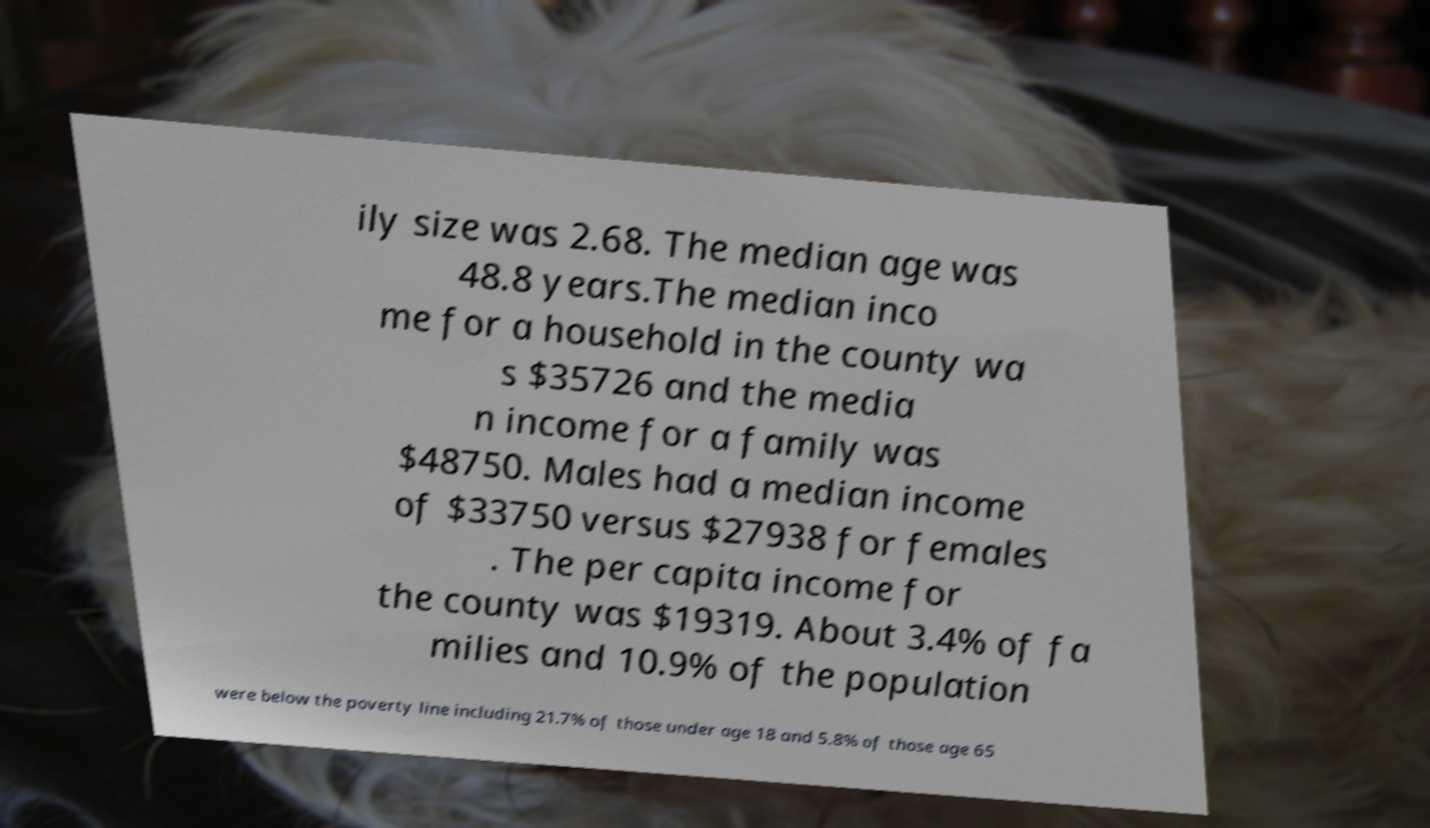What messages or text are displayed in this image? I need them in a readable, typed format. ily size was 2.68. The median age was 48.8 years.The median inco me for a household in the county wa s $35726 and the media n income for a family was $48750. Males had a median income of $33750 versus $27938 for females . The per capita income for the county was $19319. About 3.4% of fa milies and 10.9% of the population were below the poverty line including 21.7% of those under age 18 and 5.8% of those age 65 